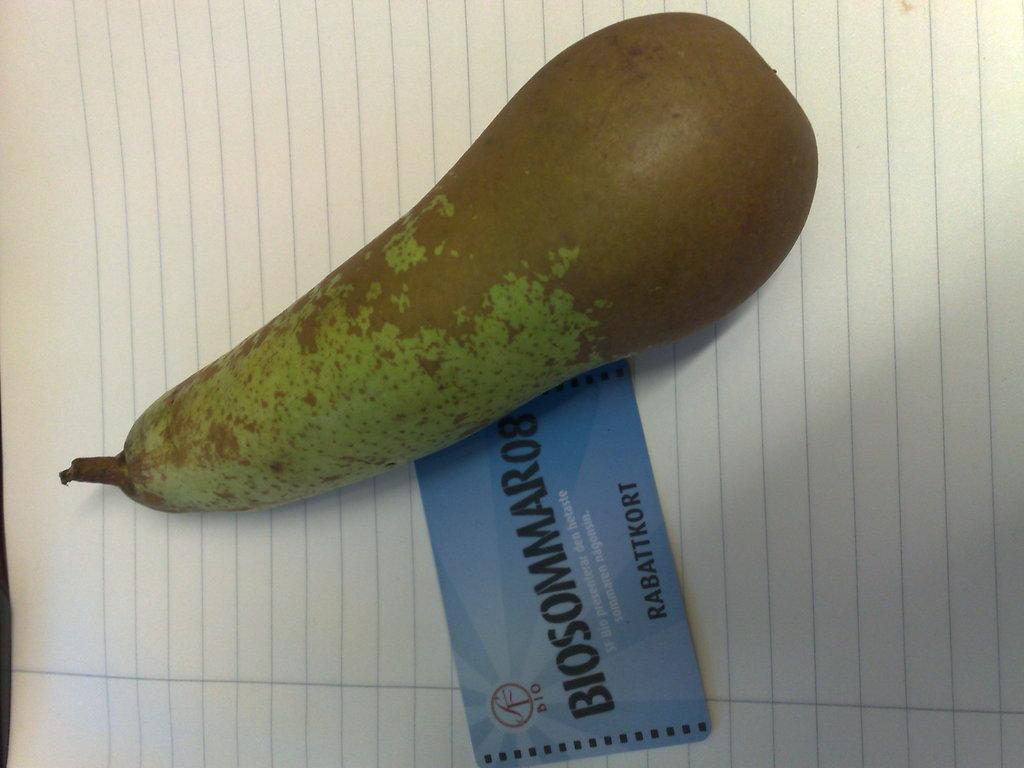What is the main object in the image? There is a bottle gourd in the image. How is the bottle gourd positioned in the image? The bottle gourd is placed on a paper. Are there any other objects related to communication or identification in the image? Yes, there is a visiting card in the image. How many cubs are playing with the bottle gourd in the image? There are no cubs present in the image; it only features a bottle gourd, a paper, and a visiting card. What type of hands are holding the bottle gourd in the image? There are no hands holding the bottle gourd in the image; it is placed on a paper. 